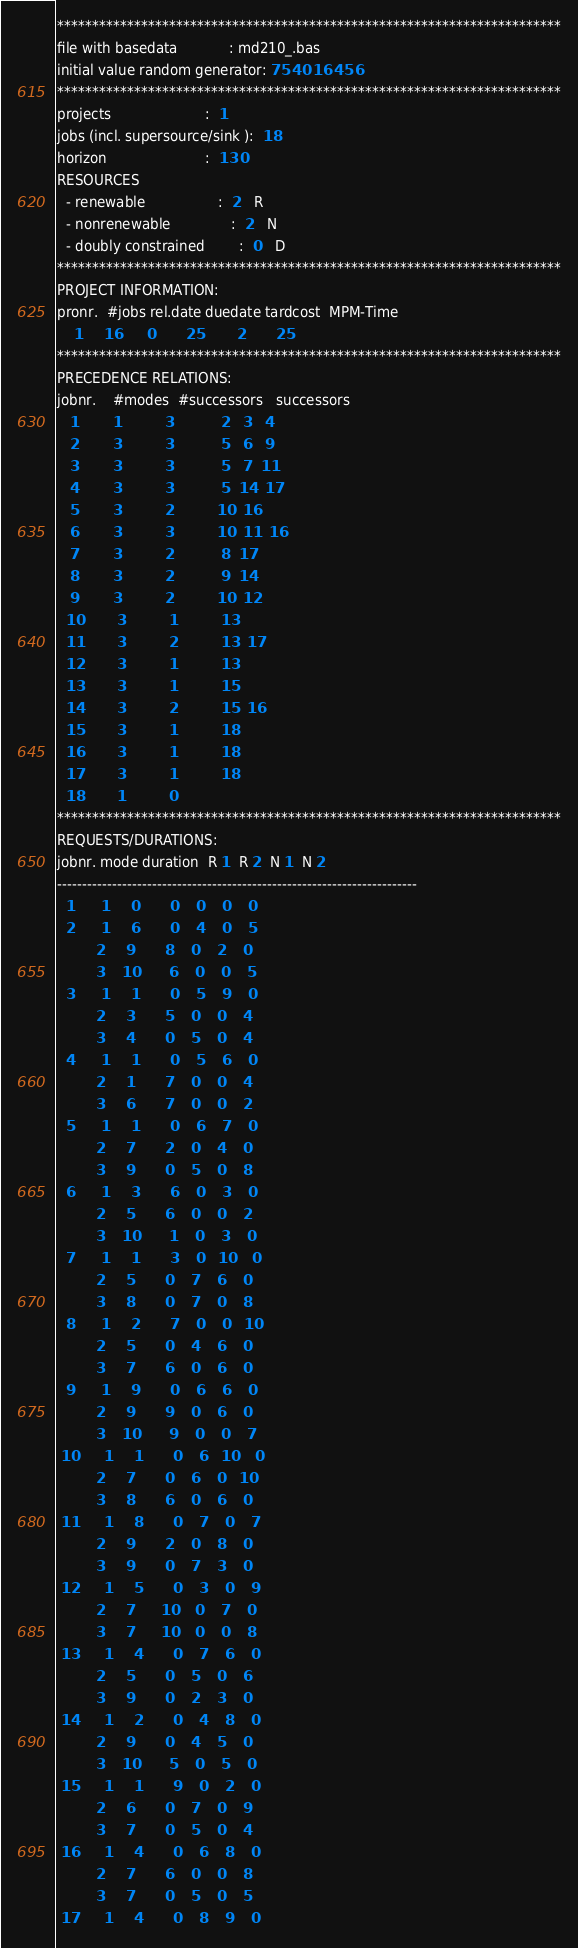Convert code to text. <code><loc_0><loc_0><loc_500><loc_500><_ObjectiveC_>************************************************************************
file with basedata            : md210_.bas
initial value random generator: 754016456
************************************************************************
projects                      :  1
jobs (incl. supersource/sink ):  18
horizon                       :  130
RESOURCES
  - renewable                 :  2   R
  - nonrenewable              :  2   N
  - doubly constrained        :  0   D
************************************************************************
PROJECT INFORMATION:
pronr.  #jobs rel.date duedate tardcost  MPM-Time
    1     16      0       25        2       25
************************************************************************
PRECEDENCE RELATIONS:
jobnr.    #modes  #successors   successors
   1        1          3           2   3   4
   2        3          3           5   6   9
   3        3          3           5   7  11
   4        3          3           5  14  17
   5        3          2          10  16
   6        3          3          10  11  16
   7        3          2           8  17
   8        3          2           9  14
   9        3          2          10  12
  10        3          1          13
  11        3          2          13  17
  12        3          1          13
  13        3          1          15
  14        3          2          15  16
  15        3          1          18
  16        3          1          18
  17        3          1          18
  18        1          0        
************************************************************************
REQUESTS/DURATIONS:
jobnr. mode duration  R 1  R 2  N 1  N 2
------------------------------------------------------------------------
  1      1     0       0    0    0    0
  2      1     6       0    4    0    5
         2     9       8    0    2    0
         3    10       6    0    0    5
  3      1     1       0    5    9    0
         2     3       5    0    0    4
         3     4       0    5    0    4
  4      1     1       0    5    6    0
         2     1       7    0    0    4
         3     6       7    0    0    2
  5      1     1       0    6    7    0
         2     7       2    0    4    0
         3     9       0    5    0    8
  6      1     3       6    0    3    0
         2     5       6    0    0    2
         3    10       1    0    3    0
  7      1     1       3    0   10    0
         2     5       0    7    6    0
         3     8       0    7    0    8
  8      1     2       7    0    0   10
         2     5       0    4    6    0
         3     7       6    0    6    0
  9      1     9       0    6    6    0
         2     9       9    0    6    0
         3    10       9    0    0    7
 10      1     1       0    6   10    0
         2     7       0    6    0   10
         3     8       6    0    6    0
 11      1     8       0    7    0    7
         2     9       2    0    8    0
         3     9       0    7    3    0
 12      1     5       0    3    0    9
         2     7      10    0    7    0
         3     7      10    0    0    8
 13      1     4       0    7    6    0
         2     5       0    5    0    6
         3     9       0    2    3    0
 14      1     2       0    4    8    0
         2     9       0    4    5    0
         3    10       5    0    5    0
 15      1     1       9    0    2    0
         2     6       0    7    0    9
         3     7       0    5    0    4
 16      1     4       0    6    8    0
         2     7       6    0    0    8
         3     7       0    5    0    5
 17      1     4       0    8    9    0</code> 